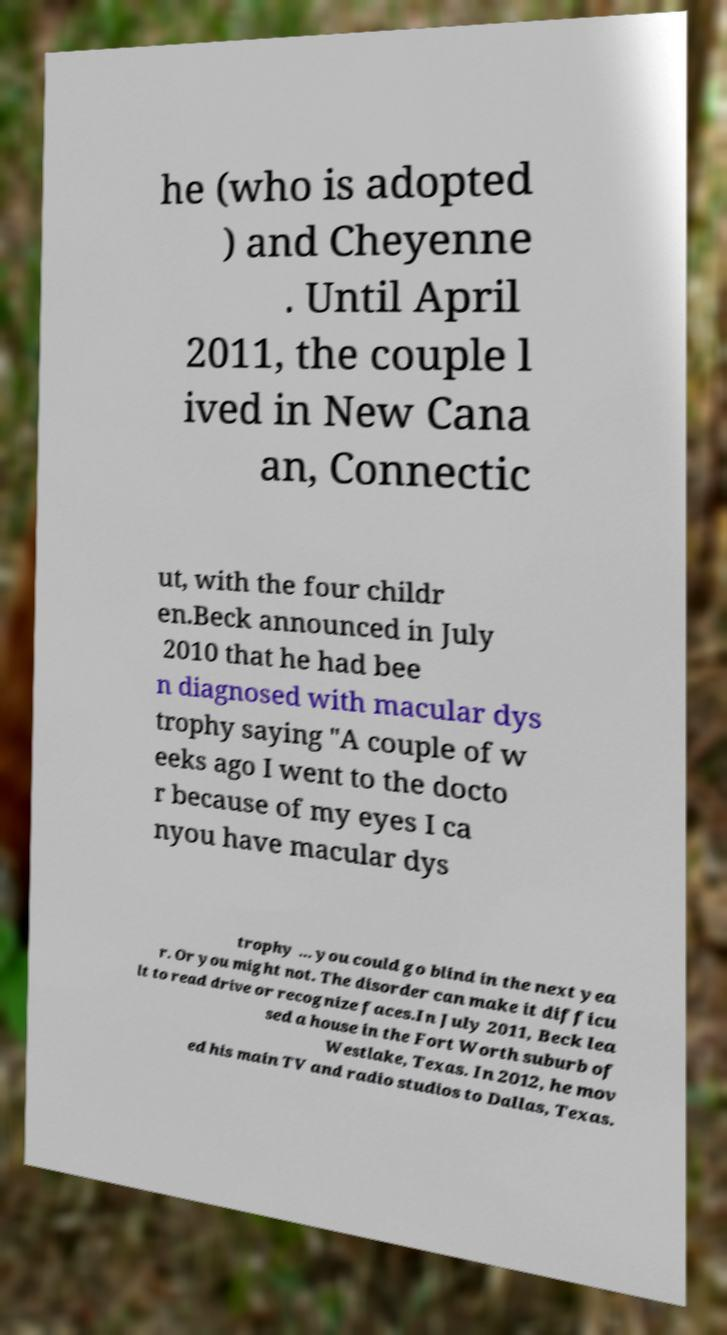Please read and relay the text visible in this image. What does it say? he (who is adopted ) and Cheyenne . Until April 2011, the couple l ived in New Cana an, Connectic ut, with the four childr en.Beck announced in July 2010 that he had bee n diagnosed with macular dys trophy saying "A couple of w eeks ago I went to the docto r because of my eyes I ca nyou have macular dys trophy ... you could go blind in the next yea r. Or you might not. The disorder can make it difficu lt to read drive or recognize faces.In July 2011, Beck lea sed a house in the Fort Worth suburb of Westlake, Texas. In 2012, he mov ed his main TV and radio studios to Dallas, Texas. 